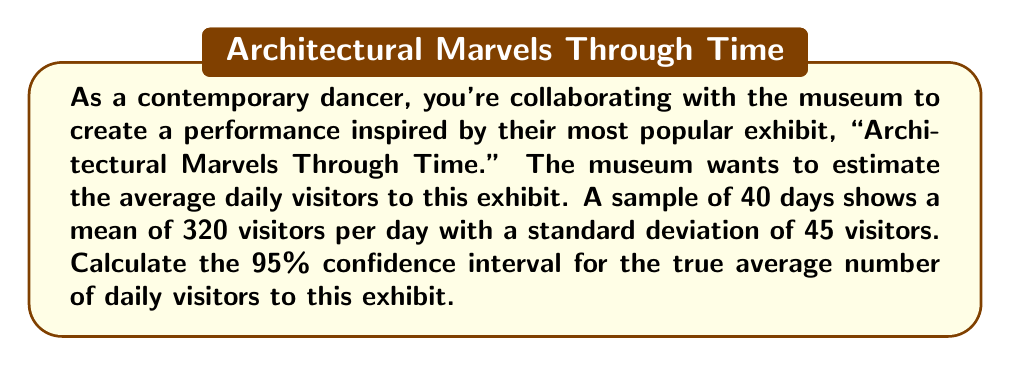Can you solve this math problem? Let's approach this step-by-step:

1) We're given:
   - Sample size (n) = 40
   - Sample mean ($\bar{x}$) = 320
   - Sample standard deviation (s) = 45
   - Confidence level = 95%

2) For a 95% confidence interval, we use a z-score of 1.96.

3) The formula for the confidence interval is:

   $$\bar{x} \pm z \cdot \frac{s}{\sqrt{n}}$$

4) Let's calculate the standard error:
   
   $$\frac{s}{\sqrt{n}} = \frac{45}{\sqrt{40}} = \frac{45}{6.325} = 7.118$$

5) Now, let's multiply this by our z-score:

   $$1.96 \cdot 7.118 = 13.951$$

6) Finally, we can calculate our confidence interval:

   Lower bound: $320 - 13.951 = 306.049$
   Upper bound: $320 + 13.951 = 333.951$

7) Rounding to the nearest whole number (as we're dealing with people):

   The 95% confidence interval is (306, 334) visitors per day.

This means we can be 95% confident that the true average number of daily visitors to the "Architectural Marvels Through Time" exhibit falls between 306 and 334.
Answer: (306, 334) visitors per day 